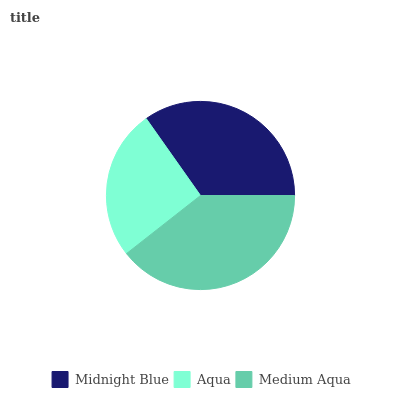Is Aqua the minimum?
Answer yes or no. Yes. Is Medium Aqua the maximum?
Answer yes or no. Yes. Is Medium Aqua the minimum?
Answer yes or no. No. Is Aqua the maximum?
Answer yes or no. No. Is Medium Aqua greater than Aqua?
Answer yes or no. Yes. Is Aqua less than Medium Aqua?
Answer yes or no. Yes. Is Aqua greater than Medium Aqua?
Answer yes or no. No. Is Medium Aqua less than Aqua?
Answer yes or no. No. Is Midnight Blue the high median?
Answer yes or no. Yes. Is Midnight Blue the low median?
Answer yes or no. Yes. Is Medium Aqua the high median?
Answer yes or no. No. Is Medium Aqua the low median?
Answer yes or no. No. 